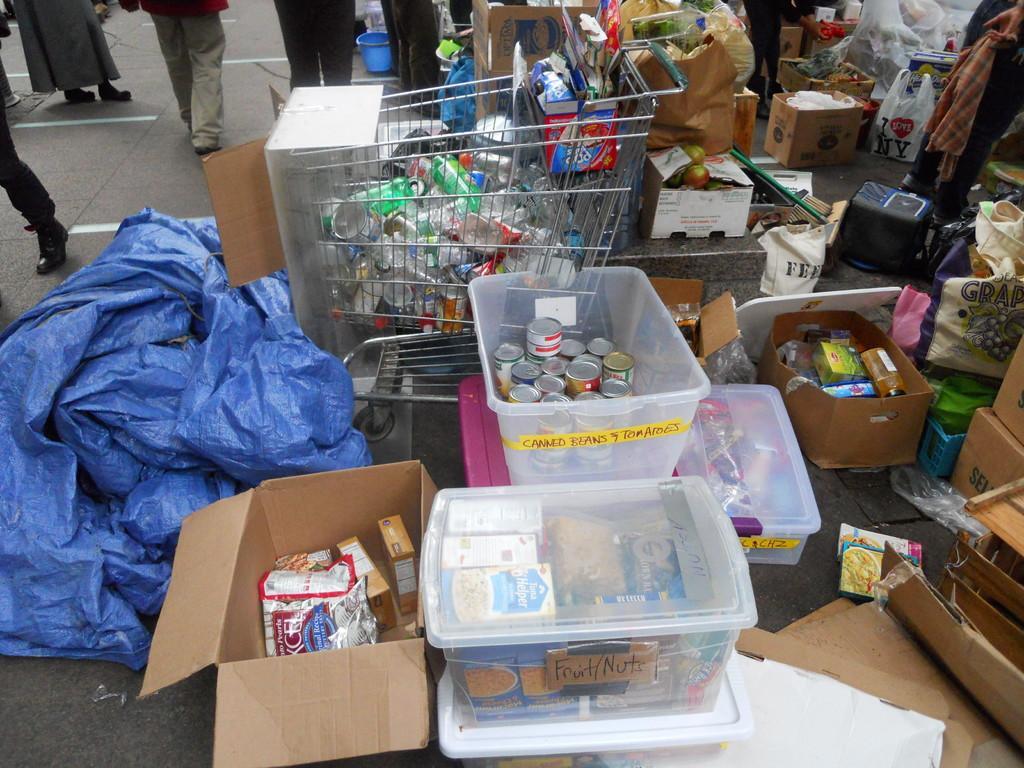In one or two sentences, can you explain what this image depicts? In this image, we can see the ground with some objects like a cover, cardboard boxes, plastic boxes. We can see a trolley, cover bags, a bucket. We can also see the legs of a few people. 